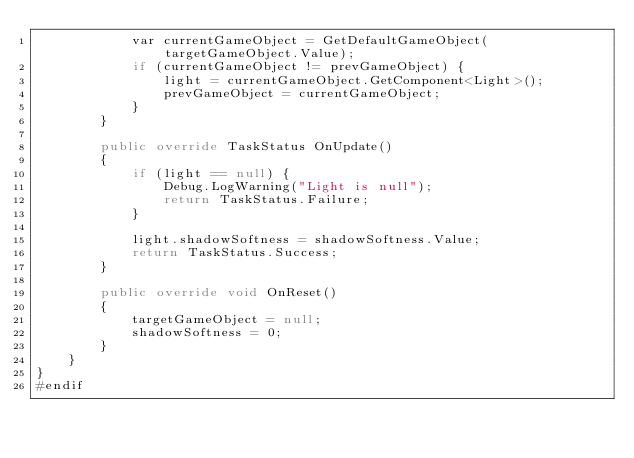<code> <loc_0><loc_0><loc_500><loc_500><_C#_>            var currentGameObject = GetDefaultGameObject(targetGameObject.Value);
            if (currentGameObject != prevGameObject) {
                light = currentGameObject.GetComponent<Light>();
                prevGameObject = currentGameObject;
            }
        }

        public override TaskStatus OnUpdate()
        {
            if (light == null) {
                Debug.LogWarning("Light is null");
                return TaskStatus.Failure;
            }

            light.shadowSoftness = shadowSoftness.Value;
            return TaskStatus.Success;
        }

        public override void OnReset()
        {
            targetGameObject = null;
            shadowSoftness = 0;
        }
    }
}
#endif</code> 